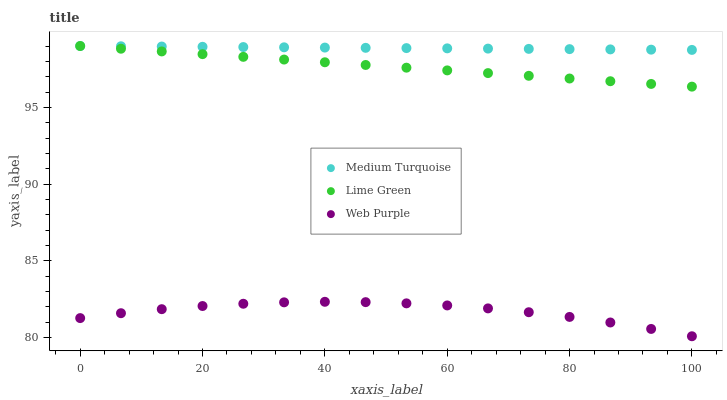Does Web Purple have the minimum area under the curve?
Answer yes or no. Yes. Does Medium Turquoise have the maximum area under the curve?
Answer yes or no. Yes. Does Lime Green have the minimum area under the curve?
Answer yes or no. No. Does Lime Green have the maximum area under the curve?
Answer yes or no. No. Is Lime Green the smoothest?
Answer yes or no. Yes. Is Web Purple the roughest?
Answer yes or no. Yes. Is Medium Turquoise the smoothest?
Answer yes or no. No. Is Medium Turquoise the roughest?
Answer yes or no. No. Does Web Purple have the lowest value?
Answer yes or no. Yes. Does Lime Green have the lowest value?
Answer yes or no. No. Does Medium Turquoise have the highest value?
Answer yes or no. Yes. Is Web Purple less than Medium Turquoise?
Answer yes or no. Yes. Is Medium Turquoise greater than Web Purple?
Answer yes or no. Yes. Does Lime Green intersect Medium Turquoise?
Answer yes or no. Yes. Is Lime Green less than Medium Turquoise?
Answer yes or no. No. Is Lime Green greater than Medium Turquoise?
Answer yes or no. No. Does Web Purple intersect Medium Turquoise?
Answer yes or no. No. 